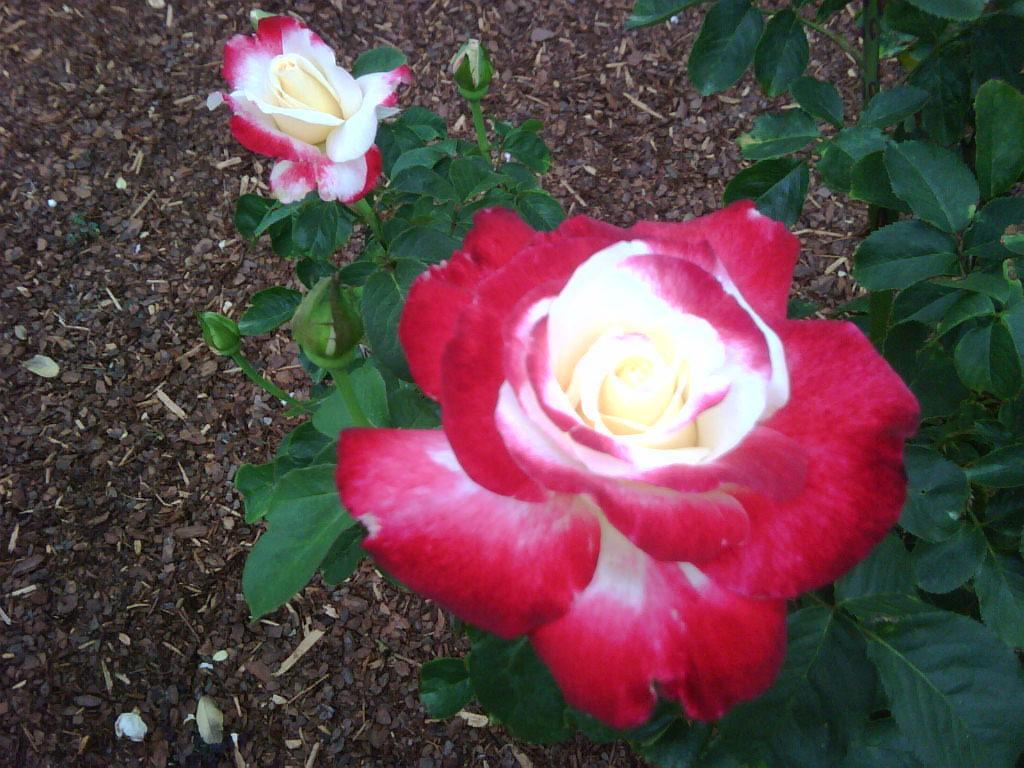What is present in the image? There is a plant in the image. How many flowers are on the plant? The plant has two flowers. What can be seen in the background of the image? There is soil visible in the background of the image. How many cows are standing on the plant's flowers in the image? There are no cows present in the image, and the flowers are not being stood on by any animals. 